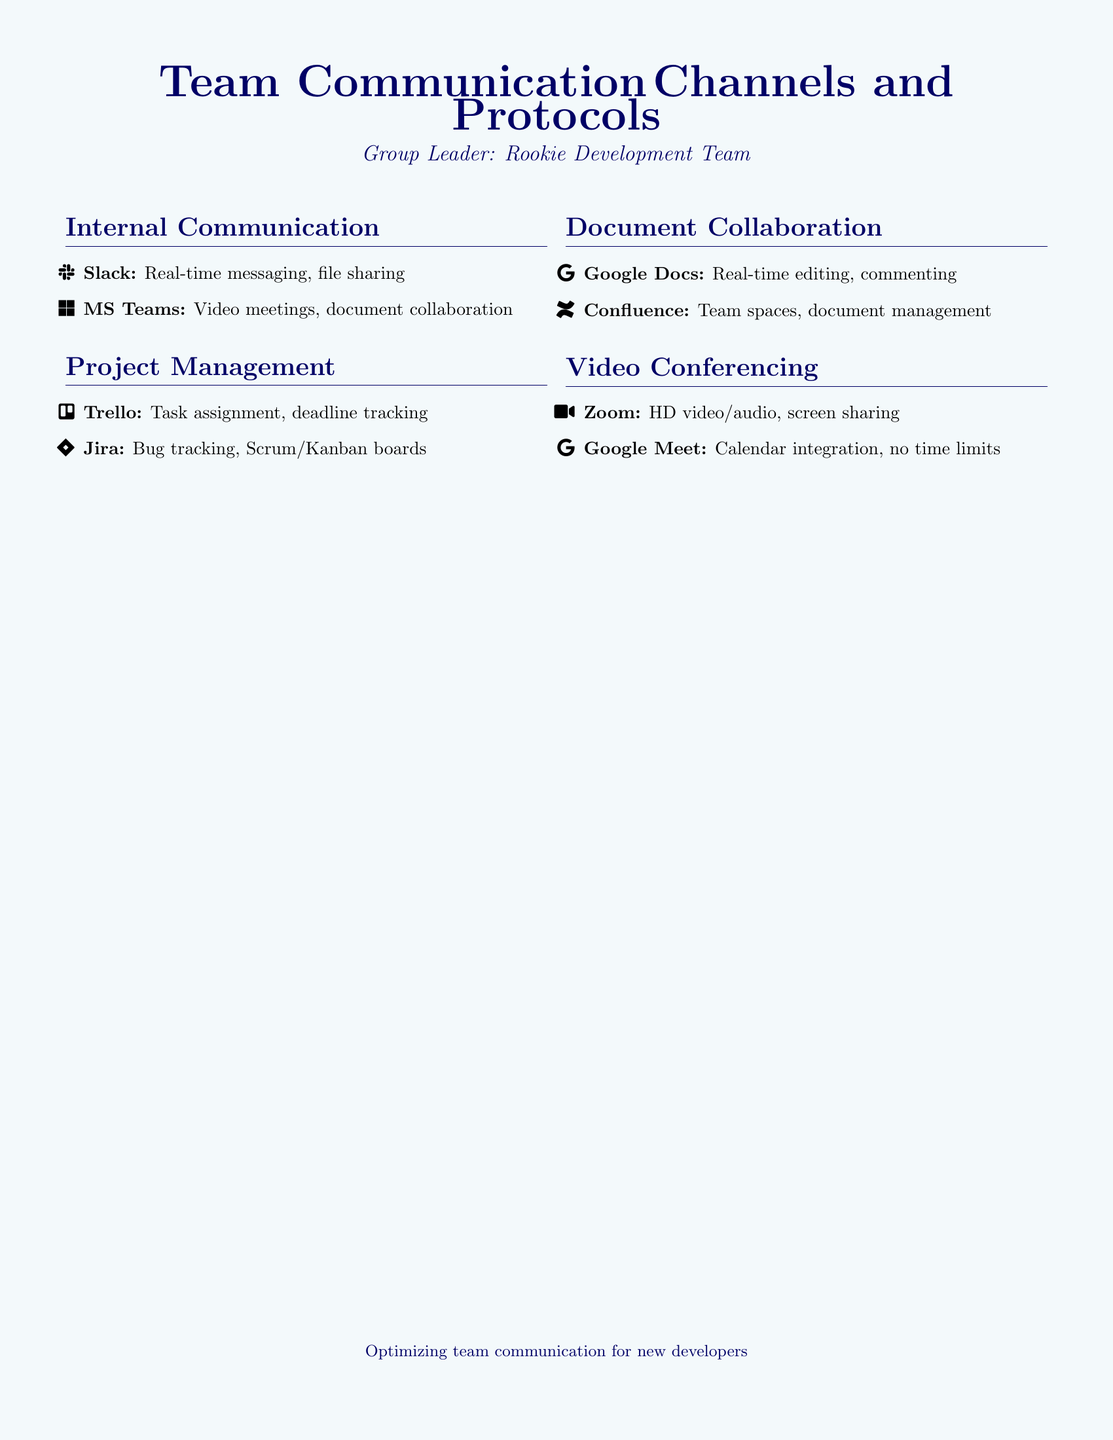What are the internal communication tools? The internal communication tools listed are Slack and MS Teams.
Answer: Slack, MS Teams What is the video conferencing tool that allows screen sharing? The document mentions Zoom as a video conferencing tool with HD video/audio and screen sharing features.
Answer: Zoom How many project management tools are listed? The document lists two project management tools: Trello and Jira.
Answer: Two Which document collaboration tool offers real-time editing? Google Docs is identified as the document collaboration tool that provides real-time editing capabilities.
Answer: Google Docs What type of meetings can be conducted on MS Teams? The document specifies that MS Teams is used for video meetings and document collaboration.
Answer: Video meetings, document collaboration Which tool supports bug tracking? Jira is the tool mentioned for bug tracking in the project management section.
Answer: Jira What is the purpose of Google Meet? The document states that Google Meet provides calendar integration and has no time limits.
Answer: Calendar integration, no time limits What do all the communication channels aim to optimize? The final note emphasizes optimizing team communication for new developers.
Answer: Team communication for new developers 